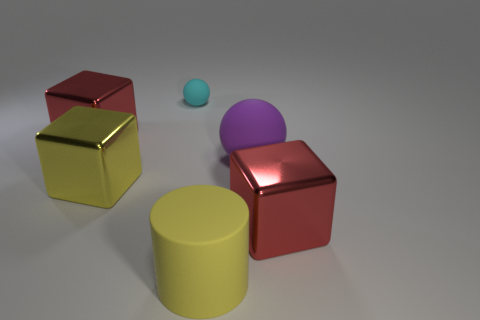Add 1 big red metallic things. How many objects exist? 7 Subtract all cylinders. How many objects are left? 5 Add 1 small matte spheres. How many small matte spheres are left? 2 Add 1 yellow rubber cylinders. How many yellow rubber cylinders exist? 2 Subtract 0 cyan cylinders. How many objects are left? 6 Subtract all large purple things. Subtract all large matte balls. How many objects are left? 4 